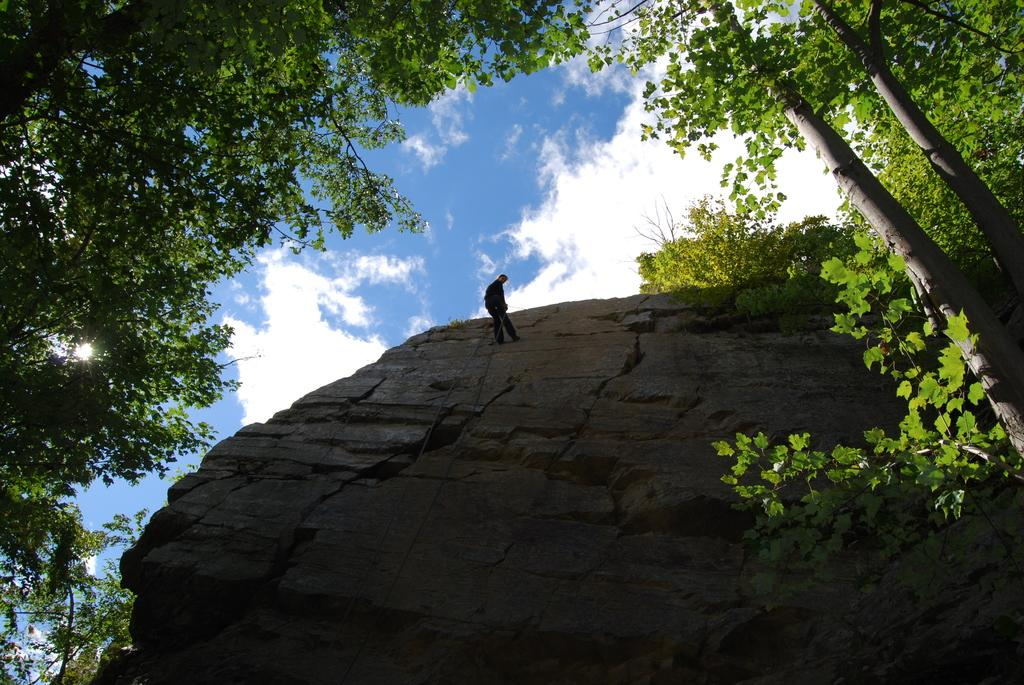What is the person in the image standing on? The person is standing on a rock hill in the image. What type of natural environment is depicted in the image? There are many trees in the image, indicating a forest or wooded area. How would you describe the weather in the image? The sky is cloudy in the image, suggesting overcast or potentially rainy conditions. What type of waves can be seen crashing against the rocks in the image? There are no waves present in the image; it depicts a person standing on a rock hill surrounded by trees and a cloudy sky. 